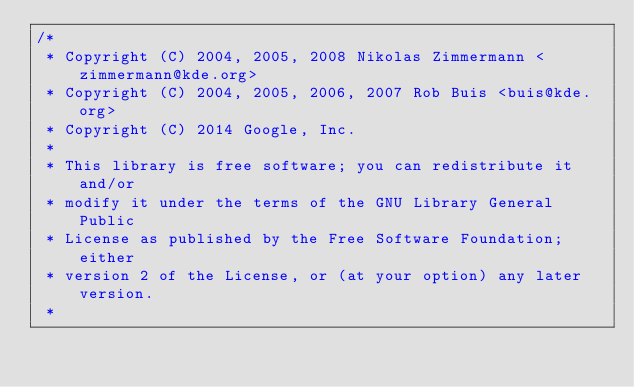Convert code to text. <code><loc_0><loc_0><loc_500><loc_500><_C_>/*
 * Copyright (C) 2004, 2005, 2008 Nikolas Zimmermann <zimmermann@kde.org>
 * Copyright (C) 2004, 2005, 2006, 2007 Rob Buis <buis@kde.org>
 * Copyright (C) 2014 Google, Inc.
 *
 * This library is free software; you can redistribute it and/or
 * modify it under the terms of the GNU Library General Public
 * License as published by the Free Software Foundation; either
 * version 2 of the License, or (at your option) any later version.
 *</code> 